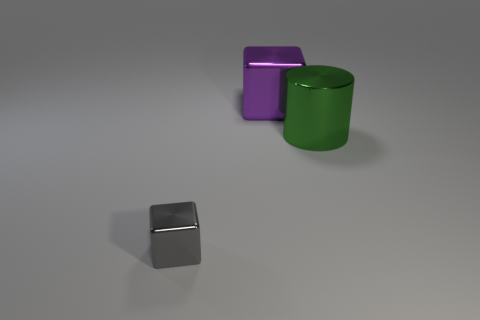Subtract all purple cylinders. Subtract all purple blocks. How many cylinders are left? 1 Add 1 red balls. How many objects exist? 4 Subtract all blocks. How many objects are left? 1 Subtract all big purple cubes. Subtract all large purple metal blocks. How many objects are left? 1 Add 1 small metallic objects. How many small metallic objects are left? 2 Add 3 large things. How many large things exist? 5 Subtract 1 green cylinders. How many objects are left? 2 